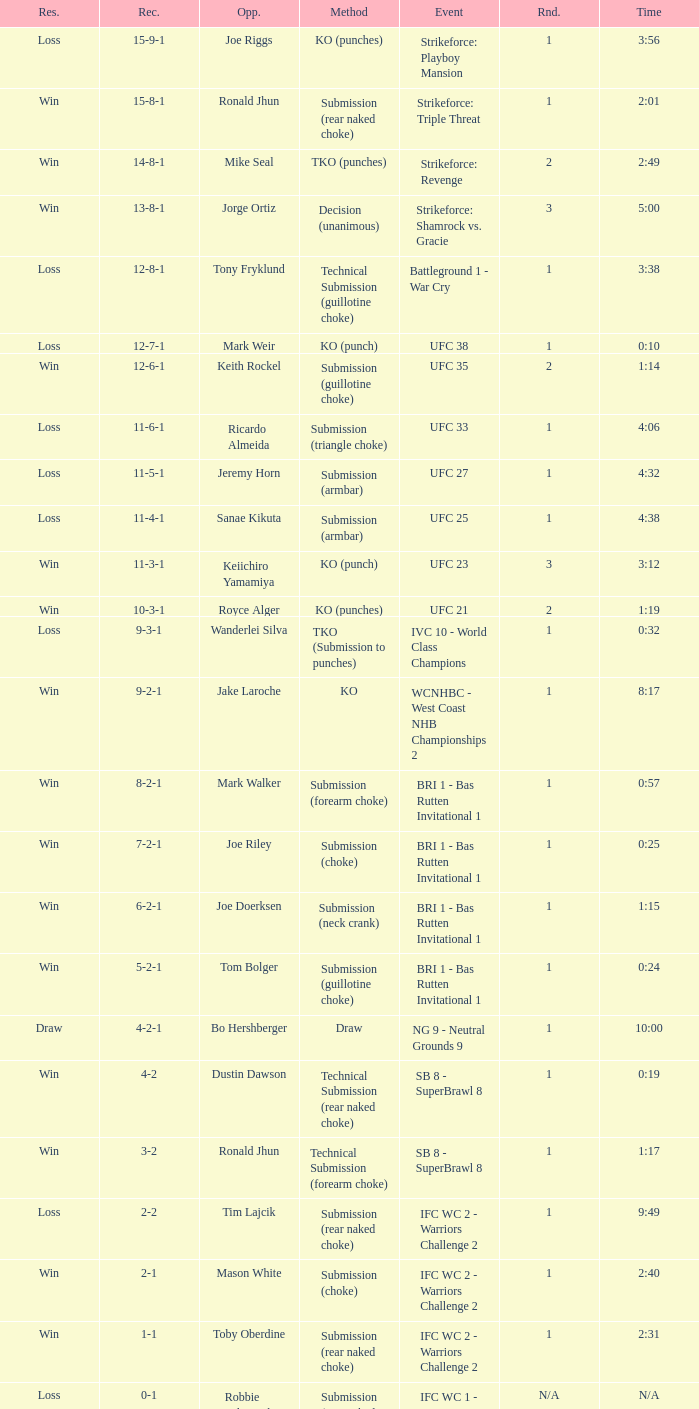What was the resolution for the fight against tom bolger by submission (guillotine choke)? Win. 